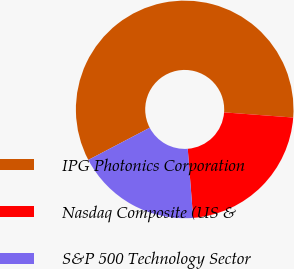Convert chart to OTSL. <chart><loc_0><loc_0><loc_500><loc_500><pie_chart><fcel>IPG Photonics Corporation<fcel>Nasdaq Composite (US &<fcel>S&P 500 Technology Sector<nl><fcel>58.87%<fcel>22.58%<fcel>18.55%<nl></chart> 